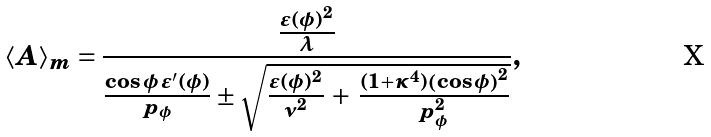<formula> <loc_0><loc_0><loc_500><loc_500>\langle A \rangle _ { m } = \frac { \frac { \varepsilon ( \phi ) ^ { 2 } } { \lambda } } { \frac { \cos { \phi } \, \varepsilon ^ { \prime } ( \phi ) } { p _ { \phi } } \pm \sqrt { \frac { \varepsilon ( \phi ) ^ { 2 } } { \nu ^ { 2 } } \, + \, \frac { ( 1 + \kappa ^ { 4 } ) \left ( \cos { \phi } \right ) ^ { 2 } } { p _ { \phi } ^ { 2 } } } } ,</formula> 